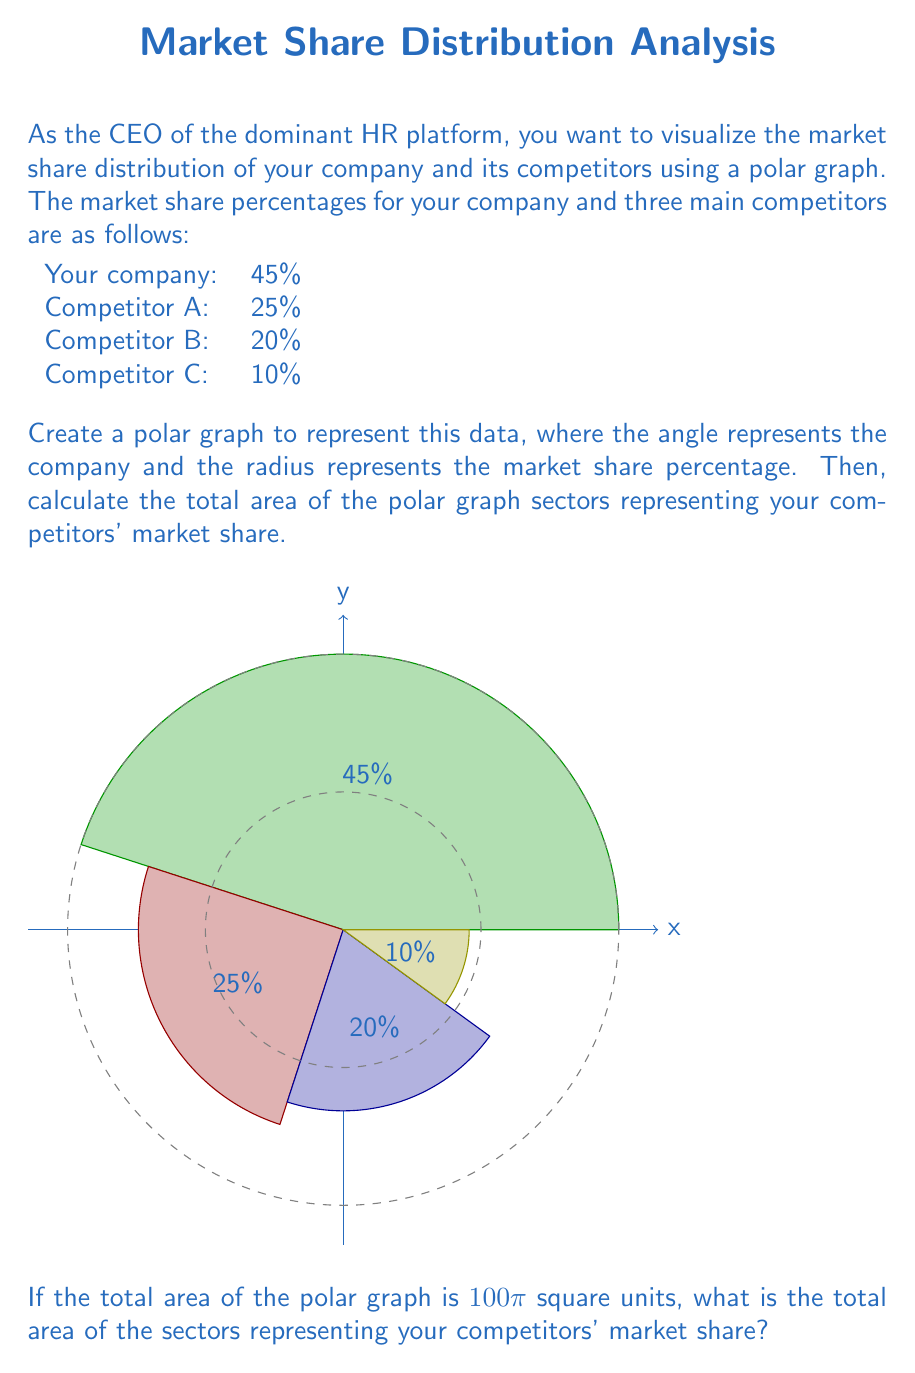Can you solve this math problem? Let's approach this step-by-step:

1) First, we need to understand that in a polar graph, the area of a sector is proportional to both its radius (representing market share) and its central angle.

2) The total area of the circle is 100π square units, which represents 100% of the market. We can use this to find the relationship between area and market share:

   $100\pi$ square units = 100% market share
   $1\pi$ square unit = 1% market share

3) Now, let's calculate the areas for each competitor:

   Competitor A: 25% = $25\pi$ square units
   Competitor B: 20% = $20\pi$ square units
   Competitor C: 10% = $10\pi$ square units

4) To find the total area of the competitors' sectors, we sum these areas:

   Total competitor area = $25\pi + 20\pi + 10\pi = 55\pi$ square units

5) We can verify this result:
   Your company's share: 45% = $45\pi$ square units
   Competitors' share: 55% = $55\pi$ square units
   Total: $45\pi + 55\pi = 100\pi$ square units (which matches the given total area)

Therefore, the total area of the sectors representing your competitors' market share is $55\pi$ square units.
Answer: $55\pi$ square units 